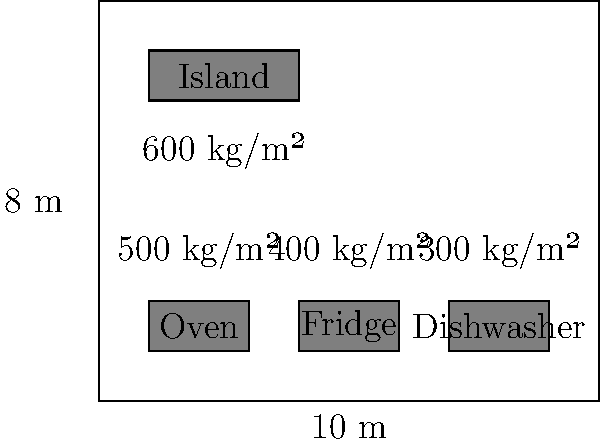As a celebrity chef planning to launch a new product line, you need to ensure your kitchen can handle the weight of various appliances and cooking activities. Given the kitchen floor plan shown, calculate the total load-bearing capacity required for the entire kitchen floor. Assume the base floor capacity is 200 kg/m² and the additional loads for different areas are as indicated in the diagram. To calculate the total load-bearing capacity required for the entire kitchen floor, we need to follow these steps:

1. Calculate the total area of the kitchen:
   Area = length × width = 10 m × 8 m = 80 m²

2. Calculate the base load for the entire floor:
   Base load = Area × Base capacity
   Base load = 80 m² × 200 kg/m² = 16,000 kg

3. Calculate additional loads for specific areas:
   a) Oven area: 2 m × 1 m × 500 kg/m² = 1,000 kg
   b) Fridge area: 2 m × 1 m × 400 kg/m² = 800 kg
   c) Dishwasher area: 2 m × 1 m × 300 kg/m² = 600 kg
   d) Island area: 3 m × 1 m × 600 kg/m² = 1,800 kg

4. Sum up all the loads:
   Total load = Base load + Oven load + Fridge load + Dishwasher load + Island load
   Total load = 16,000 kg + 1,000 kg + 800 kg + 600 kg + 1,800 kg = 20,200 kg

5. Convert the total load to the required load-bearing capacity in kg/m²:
   Required capacity = Total load ÷ Total area
   Required capacity = 20,200 kg ÷ 80 m² = 252.5 kg/m²

Therefore, the total load-bearing capacity required for the entire kitchen floor is 252.5 kg/m².
Answer: 252.5 kg/m² 